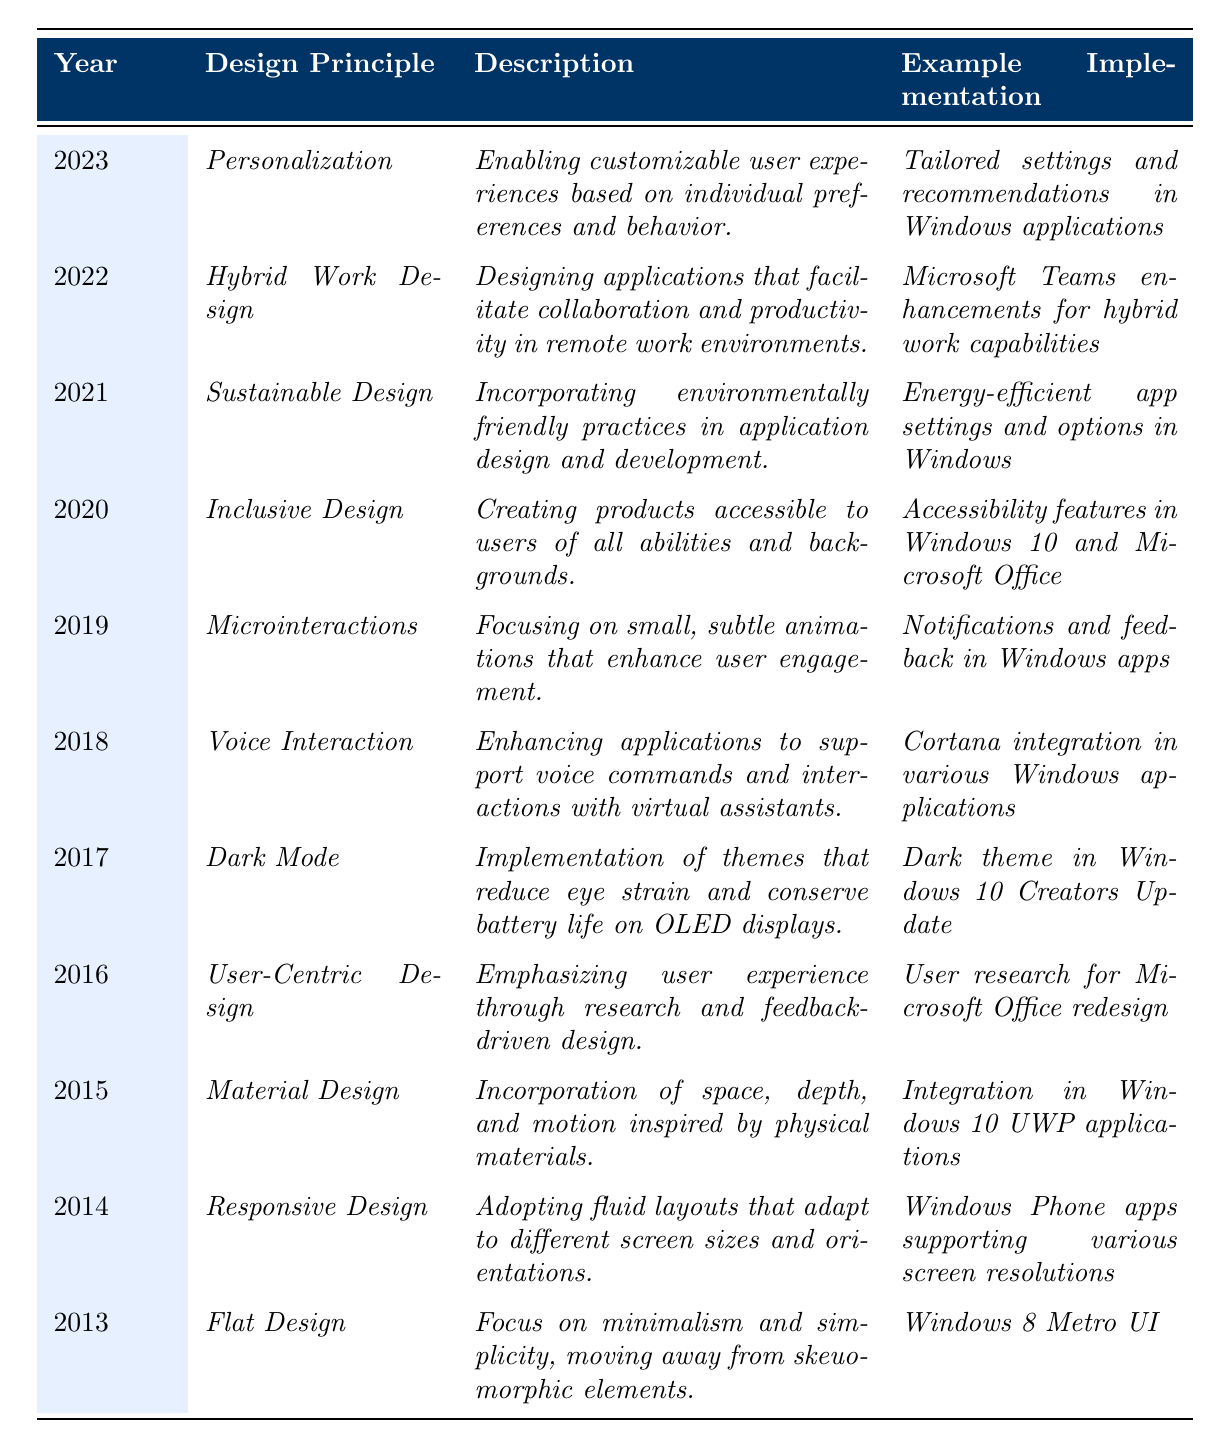What design principle was introduced in 2023? The table shows that the design principle for the year 2023 is "Personalization."
Answer: Personalization Which year marked the introduction of "Dark Mode"? The table lists "Dark Mode" under the year 2017.
Answer: 2017 How many design principles were introduced from 2013 to 2023? The table displays a total of 11 entries (one for each year from 2013 to 2023), indicating 11 design principles were introduced.
Answer: 11 Is "User-Centric Design" related to enhancing user experience? The description for "User-Centric Design" mentions emphasizing user experience, confirming the relationship.
Answer: Yes What is the difference in the years between "Material Design" and "Inclusive Design"? "Material Design" was introduced in 2015, and "Inclusive Design" in 2020. The difference is 2020 - 2015 = 5 years.
Answer: 5 years Which design principle focuses on accessibility for all users? The principle listed as "Inclusive Design" includes creating products for users of all abilities.
Answer: Inclusive Design Which two design principles were introduced in consecutive years? "Microinteractions" (2019) and "Voice Interaction" (2018) were introduced in the years following each other in the table.
Answer: Microinteractions and Voice Interaction Which design principle emphasizes environmentally friendly practices? The table indicates "Sustainable Design" in 2021 as emphasizing environmentally friendly practices.
Answer: Sustainable Design What was the most recent design principle and its example implementation? The table shows the most recent design principle (2023) is "Personalization," with implementations including tailored settings in Windows applications.
Answer: Personalization; tailored settings in Windows applications What trend appears to be gradually increasing in recent years based on the table? The increasing relevance of user experience and customization from "User-Centric Design" to "Personalization" suggests a trend toward enhancing user engagement.
Answer: Enhanced user engagement and customization 